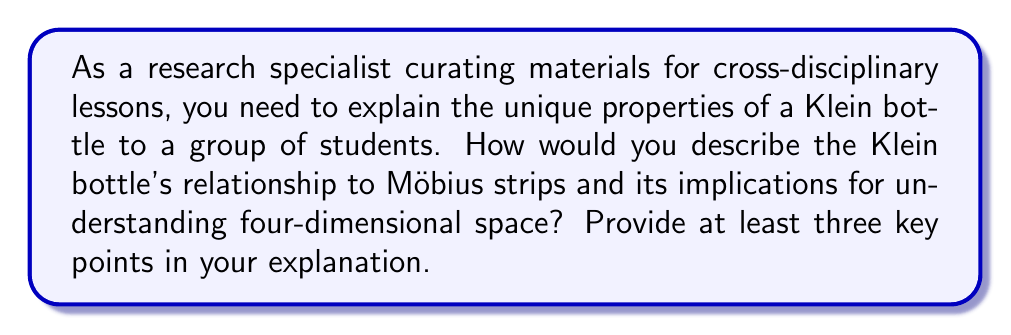Give your solution to this math problem. To answer this question, we need to understand the properties of a Klein bottle and its relationship to other topological objects. Let's break it down step-by-step:

1. Klein bottle properties:
   a) The Klein bottle is a non-orientable surface, meaning it has only one side and no boundary.
   b) It cannot be embedded in three-dimensional space without self-intersection.
   c) It can be constructed by gluing two Möbius strips together along their boundaries.

2. Relationship to Möbius strips:
   a) Both the Klein bottle and Möbius strip are non-orientable surfaces.
   b) A Klein bottle can be thought of as two Möbius strips joined along their edges.
   c) The Klein bottle is a closed surface, while the Möbius strip has a boundary.

3. Four-dimensional space implications:
   a) The Klein bottle can be embedded without self-intersection in four-dimensional space.
   b) This embedding demonstrates the limitations of our three-dimensional perception.
   c) It illustrates the concept of higher-dimensional manifolds.

To visualize the Klein bottle, we can use the following parametric equations:

$$
\begin{align*}
x &= (a + \cos(\frac{v}{2})\sin(u) - \sin(\frac{v}{2})\sin(2u))\cos(v) \\
y &= (a + \cos(\frac{v}{2})\sin(u) - \sin(\frac{v}{2})\sin(2u))\sin(v) \\
z &= \sin(\frac{v}{2})\sin(u) + \cos(\frac{v}{2})\sin(2u) \\
w &= v
\end{align*}
$$

Where $u$ and $v$ are parameters ranging from 0 to $2\pi$, and $a$ is a constant determining the size of the bottle.

Key points for the explanation:

1. Non-orientability: The Klein bottle, like the Möbius strip, is a non-orientable surface. This means that if you were to travel along the surface, you could return to your starting point with your orientation reversed.

2. Relationship to Möbius strips: The Klein bottle can be constructed by joining two Möbius strips along their boundaries. This relationship helps in understanding the Klein bottle's topology.

3. Four-dimensional embedding: While the Klein bottle cannot be embedded in three-dimensional space without self-intersection, it can be perfectly embedded in four-dimensional space. This property makes it an excellent tool for introducing the concept of higher-dimensional spaces to students.
Answer: The three key points to explain the Klein bottle's properties and its relevance to understanding four-dimensional space are:

1. Non-orientability: The Klein bottle is a non-orientable surface with only one side and no boundary, similar to a Möbius strip but closed.

2. Construction from Möbius strips: A Klein bottle can be formed by gluing two Möbius strips together along their boundaries, illustrating its relationship to simpler non-orientable surfaces.

3. Four-dimensional embedding: The Klein bottle can be embedded without self-intersection in four-dimensional space, demonstrating the limitations of three-dimensional perception and introducing the concept of higher-dimensional manifolds. 